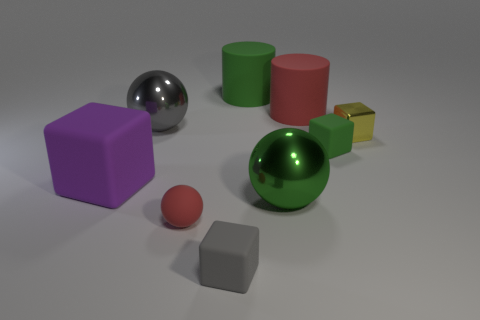What number of purple cubes are the same size as the green rubber cube?
Provide a short and direct response. 0. There is a red rubber thing behind the red matte object in front of the gray shiny object; what shape is it?
Offer a very short reply. Cylinder. The matte object that is left of the large metal sphere behind the small rubber block that is behind the big matte cube is what shape?
Offer a terse response. Cube. What number of small gray things have the same shape as the large green rubber object?
Your answer should be very brief. 0. What number of big red cylinders are on the left side of the metal ball that is behind the big block?
Provide a short and direct response. 0. How many matte things are yellow things or cylinders?
Your answer should be compact. 2. Is there a large gray thing that has the same material as the big red object?
Your answer should be very brief. No. How many objects are metallic objects to the left of the small yellow metallic cube or rubber objects that are on the right side of the gray rubber object?
Your answer should be very brief. 5. There is a metal sphere that is in front of the purple block; is it the same color as the metallic block?
Offer a very short reply. No. What number of other objects are the same color as the tiny sphere?
Give a very brief answer. 1. 